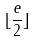Convert formula to latex. <formula><loc_0><loc_0><loc_500><loc_500>\lfloor \frac { e } { 2 } \rfloor</formula> 